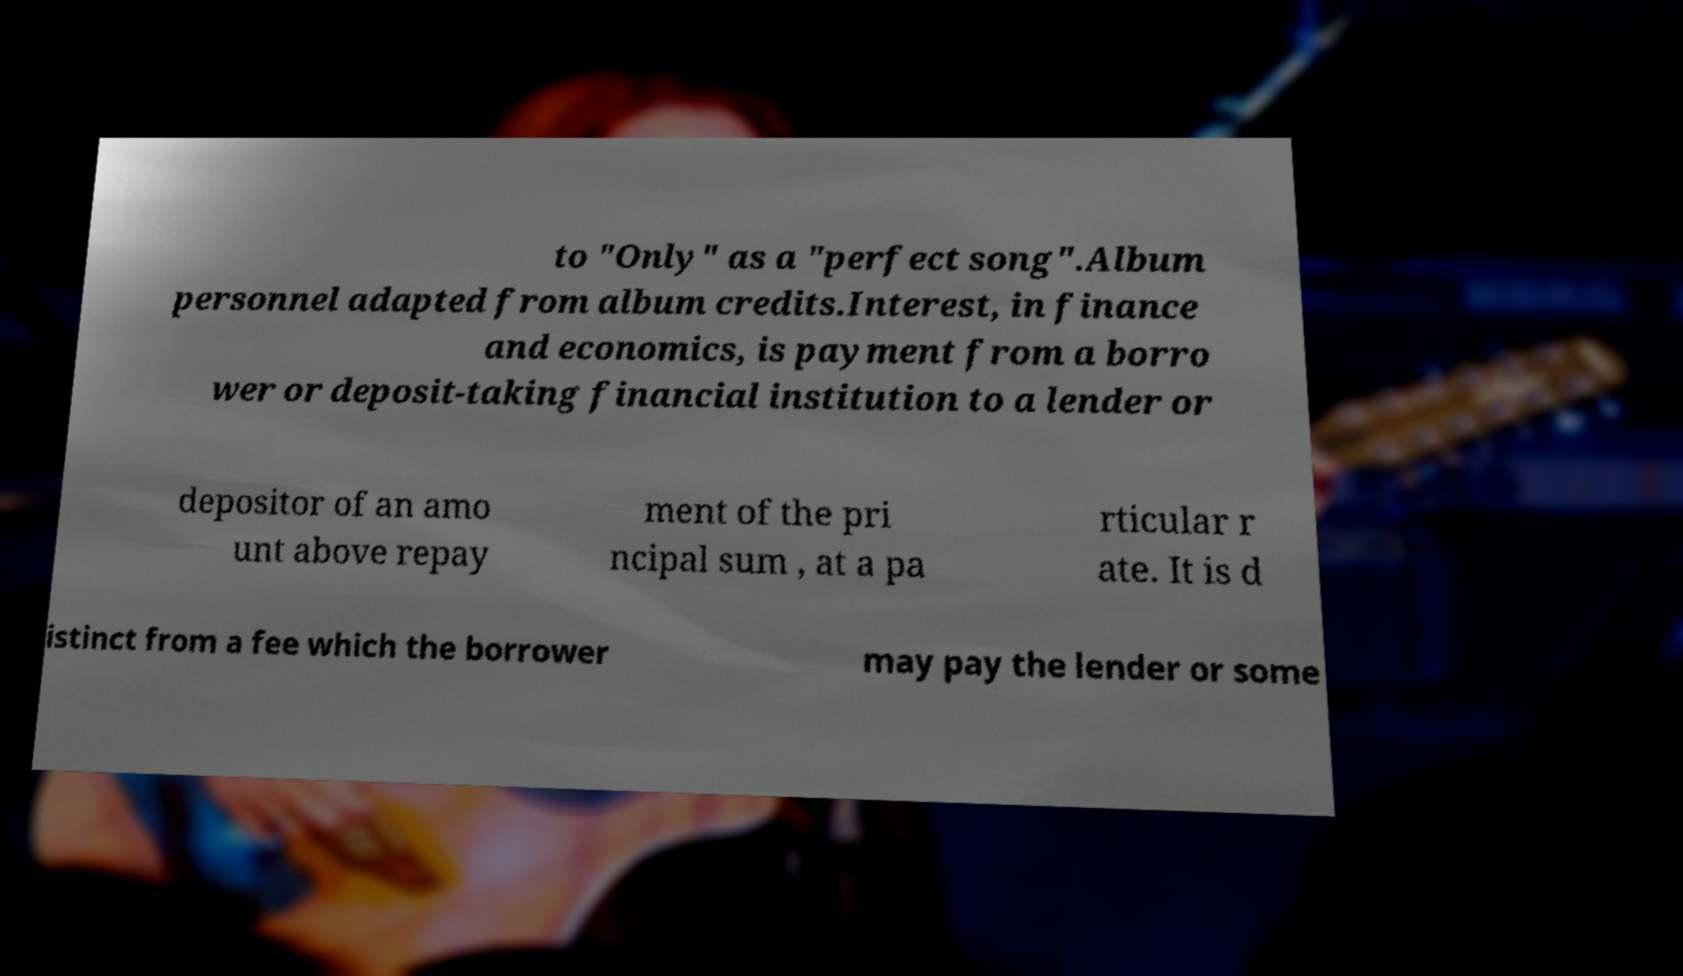What messages or text are displayed in this image? I need them in a readable, typed format. to "Only" as a "perfect song".Album personnel adapted from album credits.Interest, in finance and economics, is payment from a borro wer or deposit-taking financial institution to a lender or depositor of an amo unt above repay ment of the pri ncipal sum , at a pa rticular r ate. It is d istinct from a fee which the borrower may pay the lender or some 